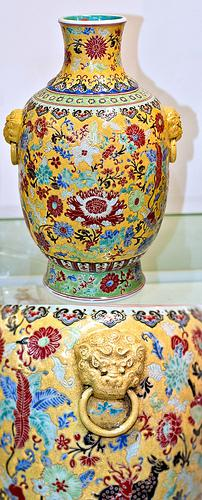Question: what are on the sides of the vase?
Choices:
A. Lions.
B. Tigers.
C. Leopard.
D. Elephant.
Answer with the letter. Answer: A Question: where are the loops on this vase?
Choices:
A. The top.
B. The bottom.
C. The sides.
D. Inside.
Answer with the letter. Answer: C Question: what color is the flower at the bottom of the vase?
Choices:
A. Pink.
B. Purple.
C. Red.
D. Yellow.
Answer with the letter. Answer: C 